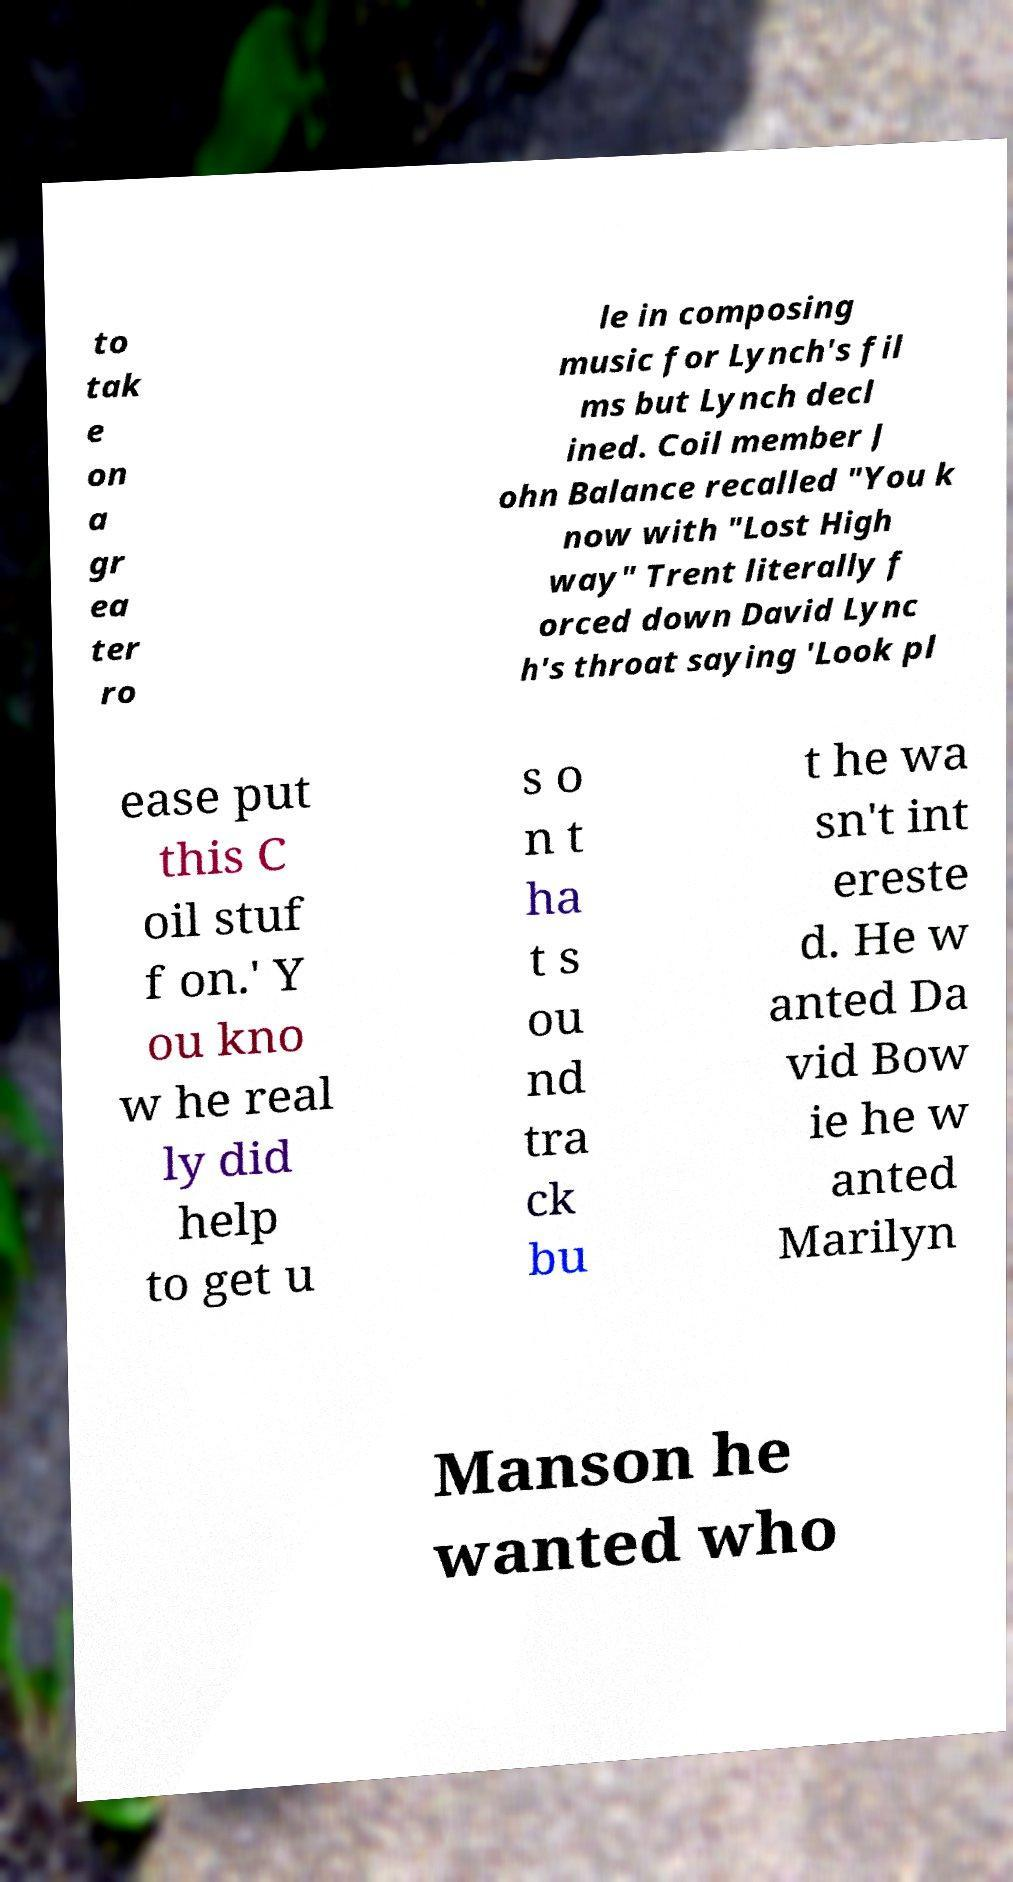Please identify and transcribe the text found in this image. to tak e on a gr ea ter ro le in composing music for Lynch's fil ms but Lynch decl ined. Coil member J ohn Balance recalled "You k now with "Lost High way" Trent literally f orced down David Lync h's throat saying 'Look pl ease put this C oil stuf f on.' Y ou kno w he real ly did help to get u s o n t ha t s ou nd tra ck bu t he wa sn't int ereste d. He w anted Da vid Bow ie he w anted Marilyn Manson he wanted who 